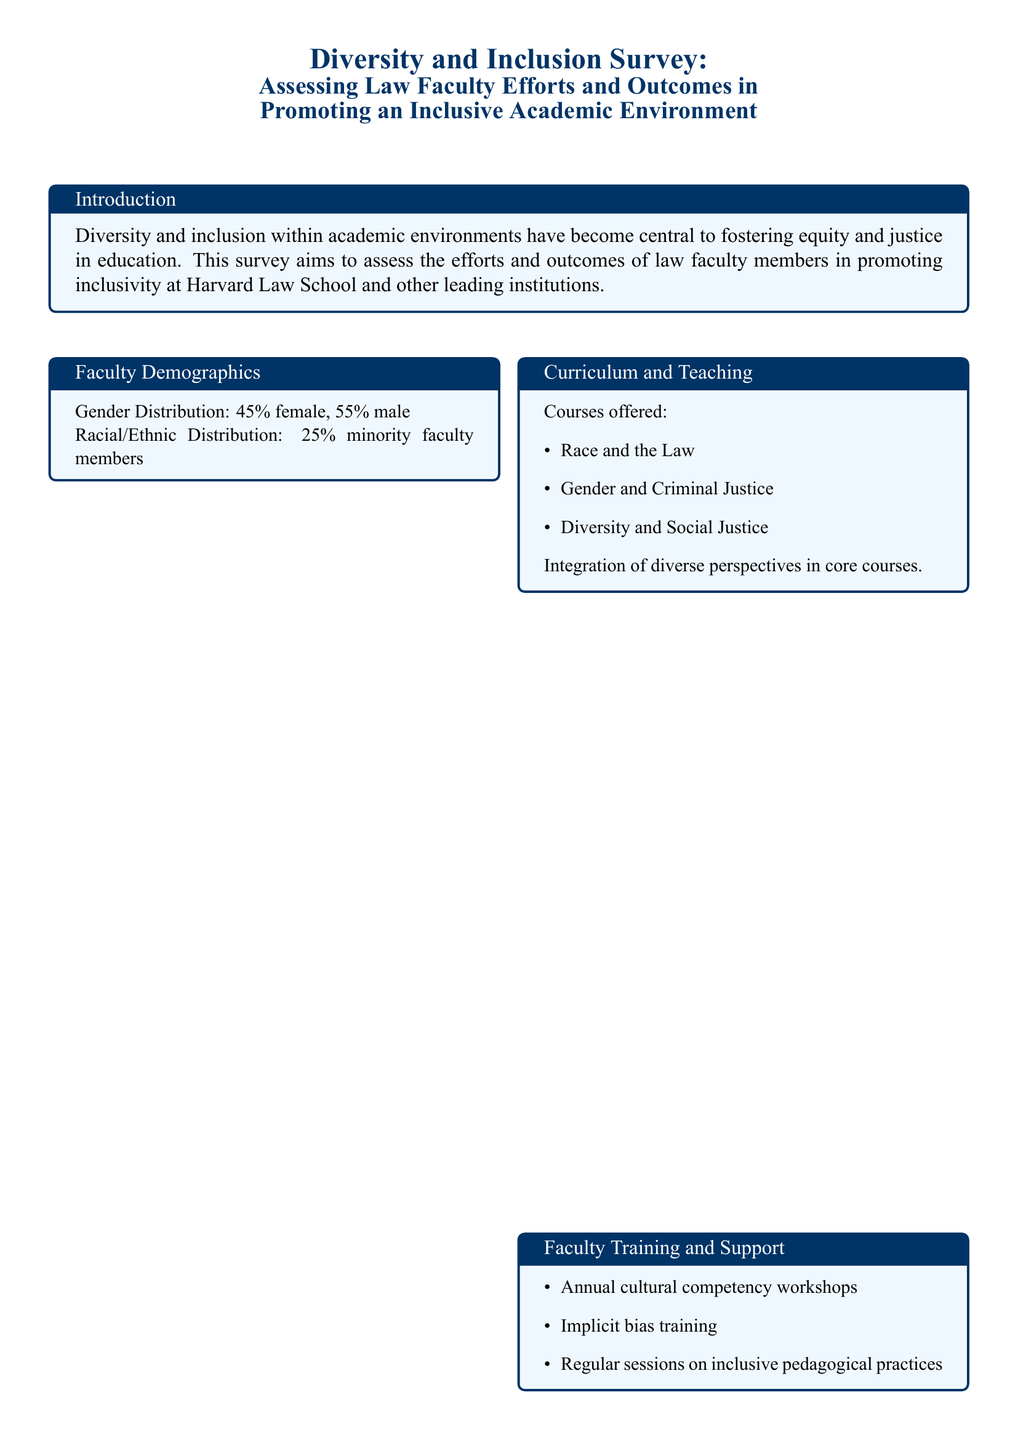what percentage of faculty members are female? The document states that the gender distribution shows 45% female faculty members.
Answer: 45% what percentage of faculty members are from minority backgrounds? The racial/ethnic distribution indicates that 25% are minority faculty members.
Answer: 25% name one course offered that focuses on diversity. The document lists several courses, one of which is "Diversity and Social Justice."
Answer: Diversity and Social Justice what type of training is provided annually for faculty? The document mentions "annual cultural competency workshops" as a type of training offered.
Answer: cultural competency workshops how has student satisfaction changed in the past five years? The document notes that there has been an "increased student satisfaction" over the past five years.
Answer: increased student satisfaction which student organization is mentioned for first-generation students? The document lists the "First Generation Student Union" as an organization that supports first-generation students.
Answer: First Generation Student Union what is one outcome related to minority student retention? A specific outcome mentioned is "higher retention rate among minority students."
Answer: higher retention rate among minority students what ongoing effort is noted in improving faculty inclusion practices? The document states there are "ongoing efforts to address implicit bias."
Answer: ongoing efforts to address implicit bias 